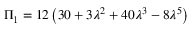<formula> <loc_0><loc_0><loc_500><loc_500>\Pi _ { 1 } = 1 2 \left ( 3 0 + 3 \lambda ^ { 2 } + 4 0 \lambda ^ { 3 } - 8 \lambda ^ { 5 } \right )</formula> 